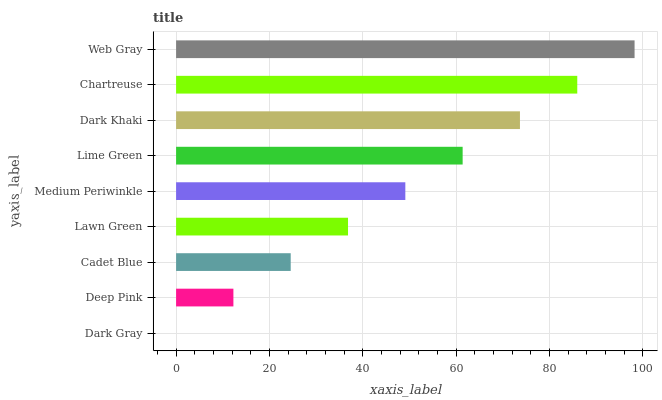Is Dark Gray the minimum?
Answer yes or no. Yes. Is Web Gray the maximum?
Answer yes or no. Yes. Is Deep Pink the minimum?
Answer yes or no. No. Is Deep Pink the maximum?
Answer yes or no. No. Is Deep Pink greater than Dark Gray?
Answer yes or no. Yes. Is Dark Gray less than Deep Pink?
Answer yes or no. Yes. Is Dark Gray greater than Deep Pink?
Answer yes or no. No. Is Deep Pink less than Dark Gray?
Answer yes or no. No. Is Medium Periwinkle the high median?
Answer yes or no. Yes. Is Medium Periwinkle the low median?
Answer yes or no. Yes. Is Chartreuse the high median?
Answer yes or no. No. Is Dark Gray the low median?
Answer yes or no. No. 